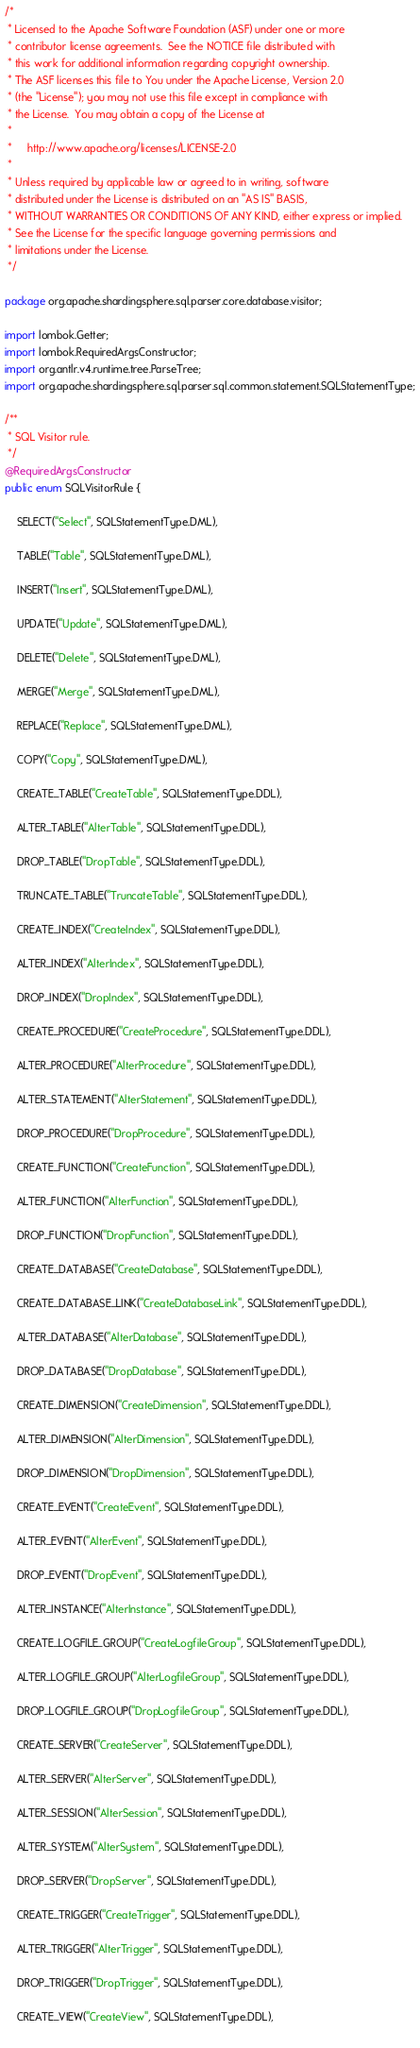Convert code to text. <code><loc_0><loc_0><loc_500><loc_500><_Java_>/*
 * Licensed to the Apache Software Foundation (ASF) under one or more
 * contributor license agreements.  See the NOTICE file distributed with
 * this work for additional information regarding copyright ownership.
 * The ASF licenses this file to You under the Apache License, Version 2.0
 * (the "License"); you may not use this file except in compliance with
 * the License.  You may obtain a copy of the License at
 *
 *     http://www.apache.org/licenses/LICENSE-2.0
 *
 * Unless required by applicable law or agreed to in writing, software
 * distributed under the License is distributed on an "AS IS" BASIS,
 * WITHOUT WARRANTIES OR CONDITIONS OF ANY KIND, either express or implied.
 * See the License for the specific language governing permissions and
 * limitations under the License.
 */

package org.apache.shardingsphere.sql.parser.core.database.visitor;

import lombok.Getter;
import lombok.RequiredArgsConstructor;
import org.antlr.v4.runtime.tree.ParseTree;
import org.apache.shardingsphere.sql.parser.sql.common.statement.SQLStatementType;

/**
 * SQL Visitor rule.
 */
@RequiredArgsConstructor
public enum SQLVisitorRule {
    
    SELECT("Select", SQLStatementType.DML),
    
    TABLE("Table", SQLStatementType.DML),
    
    INSERT("Insert", SQLStatementType.DML),
    
    UPDATE("Update", SQLStatementType.DML),
    
    DELETE("Delete", SQLStatementType.DML),
    
    MERGE("Merge", SQLStatementType.DML),
    
    REPLACE("Replace", SQLStatementType.DML),
    
    COPY("Copy", SQLStatementType.DML),
    
    CREATE_TABLE("CreateTable", SQLStatementType.DDL),
    
    ALTER_TABLE("AlterTable", SQLStatementType.DDL),
    
    DROP_TABLE("DropTable", SQLStatementType.DDL),
    
    TRUNCATE_TABLE("TruncateTable", SQLStatementType.DDL),
    
    CREATE_INDEX("CreateIndex", SQLStatementType.DDL),
    
    ALTER_INDEX("AlterIndex", SQLStatementType.DDL),
    
    DROP_INDEX("DropIndex", SQLStatementType.DDL),
    
    CREATE_PROCEDURE("CreateProcedure", SQLStatementType.DDL),
    
    ALTER_PROCEDURE("AlterProcedure", SQLStatementType.DDL),

    ALTER_STATEMENT("AlterStatement", SQLStatementType.DDL),

    DROP_PROCEDURE("DropProcedure", SQLStatementType.DDL),
    
    CREATE_FUNCTION("CreateFunction", SQLStatementType.DDL),
    
    ALTER_FUNCTION("AlterFunction", SQLStatementType.DDL),
    
    DROP_FUNCTION("DropFunction", SQLStatementType.DDL),
    
    CREATE_DATABASE("CreateDatabase", SQLStatementType.DDL),

    CREATE_DATABASE_LINK("CreateDatabaseLink", SQLStatementType.DDL),
    
    ALTER_DATABASE("AlterDatabase", SQLStatementType.DDL),
    
    DROP_DATABASE("DropDatabase", SQLStatementType.DDL),
    
    CREATE_DIMENSION("CreateDimension", SQLStatementType.DDL),

    ALTER_DIMENSION("AlterDimension", SQLStatementType.DDL),

    DROP_DIMENSION("DropDimension", SQLStatementType.DDL),
    
    CREATE_EVENT("CreateEvent", SQLStatementType.DDL),
    
    ALTER_EVENT("AlterEvent", SQLStatementType.DDL),
    
    DROP_EVENT("DropEvent", SQLStatementType.DDL),
    
    ALTER_INSTANCE("AlterInstance", SQLStatementType.DDL),
    
    CREATE_LOGFILE_GROUP("CreateLogfileGroup", SQLStatementType.DDL),
    
    ALTER_LOGFILE_GROUP("AlterLogfileGroup", SQLStatementType.DDL),
    
    DROP_LOGFILE_GROUP("DropLogfileGroup", SQLStatementType.DDL),
    
    CREATE_SERVER("CreateServer", SQLStatementType.DDL),
    
    ALTER_SERVER("AlterServer", SQLStatementType.DDL),
    
    ALTER_SESSION("AlterSession", SQLStatementType.DDL),
    
    ALTER_SYSTEM("AlterSystem", SQLStatementType.DDL),
    
    DROP_SERVER("DropServer", SQLStatementType.DDL),
    
    CREATE_TRIGGER("CreateTrigger", SQLStatementType.DDL),

    ALTER_TRIGGER("AlterTrigger", SQLStatementType.DDL),
    
    DROP_TRIGGER("DropTrigger", SQLStatementType.DDL),
    
    CREATE_VIEW("CreateView", SQLStatementType.DDL),
    </code> 